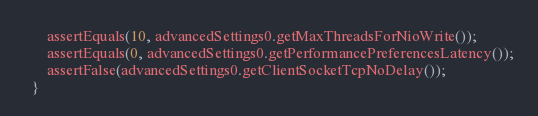<code> <loc_0><loc_0><loc_500><loc_500><_Java_>      assertEquals(10, advancedSettings0.getMaxThreadsForNioWrite());
      assertEquals(0, advancedSettings0.getPerformancePreferencesLatency());
      assertFalse(advancedSettings0.getClientSocketTcpNoDelay());
  }
</code> 